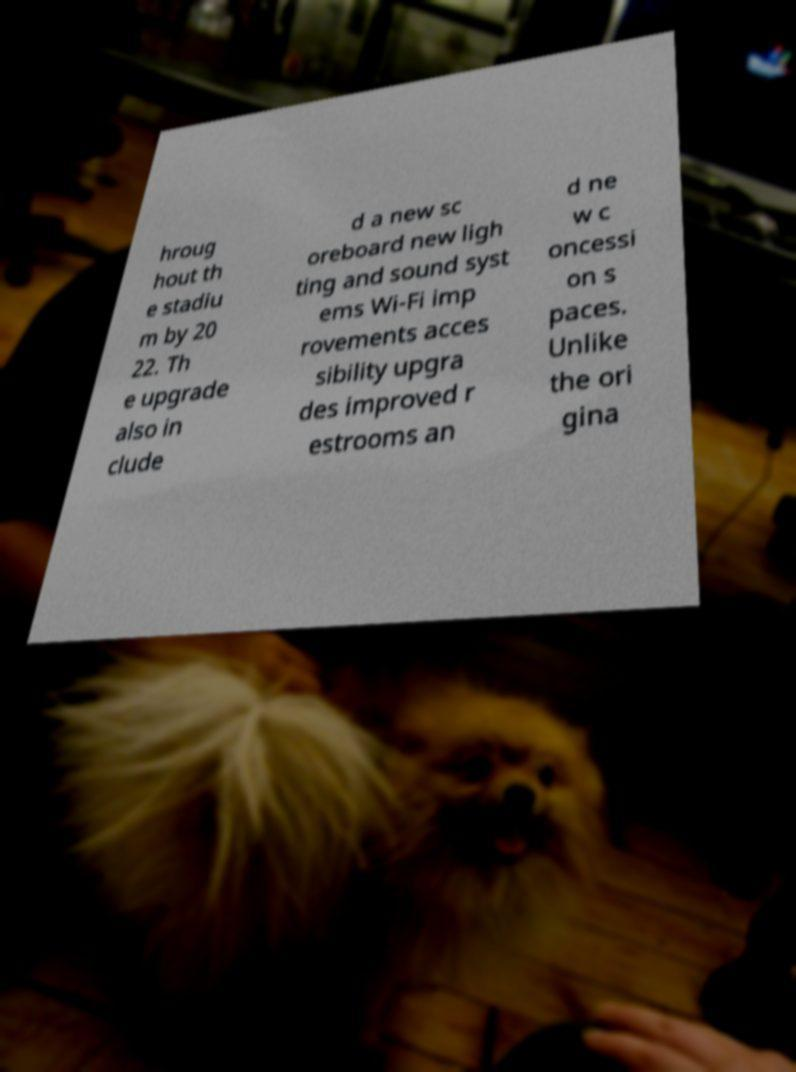Can you read and provide the text displayed in the image?This photo seems to have some interesting text. Can you extract and type it out for me? hroug hout th e stadiu m by 20 22. Th e upgrade also in clude d a new sc oreboard new ligh ting and sound syst ems Wi-Fi imp rovements acces sibility upgra des improved r estrooms an d ne w c oncessi on s paces. Unlike the ori gina 